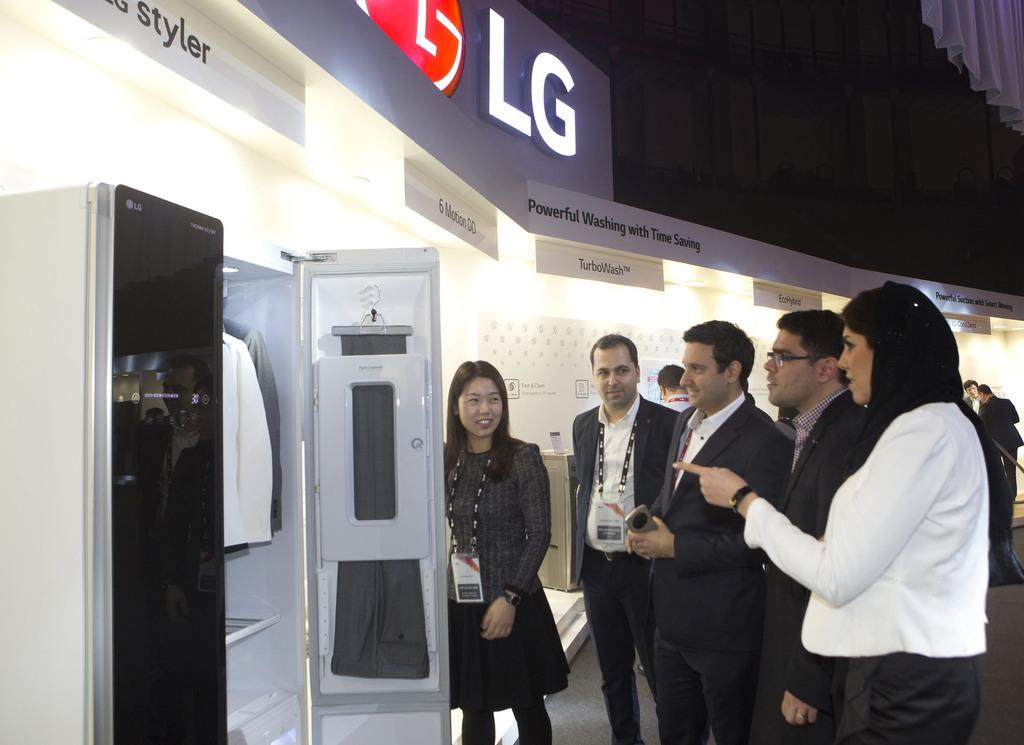Provide a one-sentence caption for the provided image. A sales team displays a product hat advertises powerful washing with time saving. 